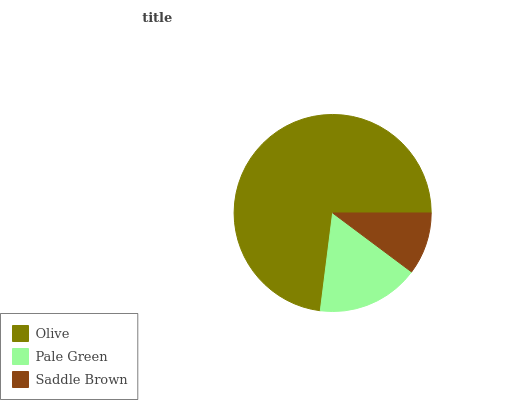Is Saddle Brown the minimum?
Answer yes or no. Yes. Is Olive the maximum?
Answer yes or no. Yes. Is Pale Green the minimum?
Answer yes or no. No. Is Pale Green the maximum?
Answer yes or no. No. Is Olive greater than Pale Green?
Answer yes or no. Yes. Is Pale Green less than Olive?
Answer yes or no. Yes. Is Pale Green greater than Olive?
Answer yes or no. No. Is Olive less than Pale Green?
Answer yes or no. No. Is Pale Green the high median?
Answer yes or no. Yes. Is Pale Green the low median?
Answer yes or no. Yes. Is Olive the high median?
Answer yes or no. No. Is Saddle Brown the low median?
Answer yes or no. No. 